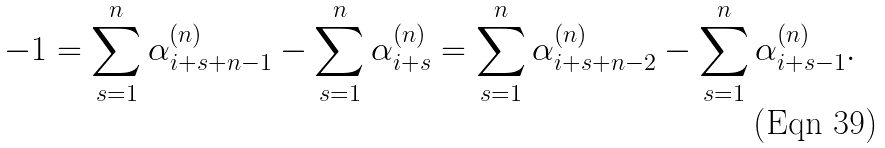Convert formula to latex. <formula><loc_0><loc_0><loc_500><loc_500>- 1 = \sum _ { s = 1 } ^ { n } \alpha ^ { ( n ) } _ { i + s + n - 1 } - \sum _ { s = 1 } ^ { n } \alpha ^ { ( n ) } _ { i + s } = \sum _ { s = 1 } ^ { n } \alpha ^ { ( n ) } _ { i + s + n - 2 } - \sum _ { s = 1 } ^ { n } \alpha ^ { ( n ) } _ { i + s - 1 } .</formula> 